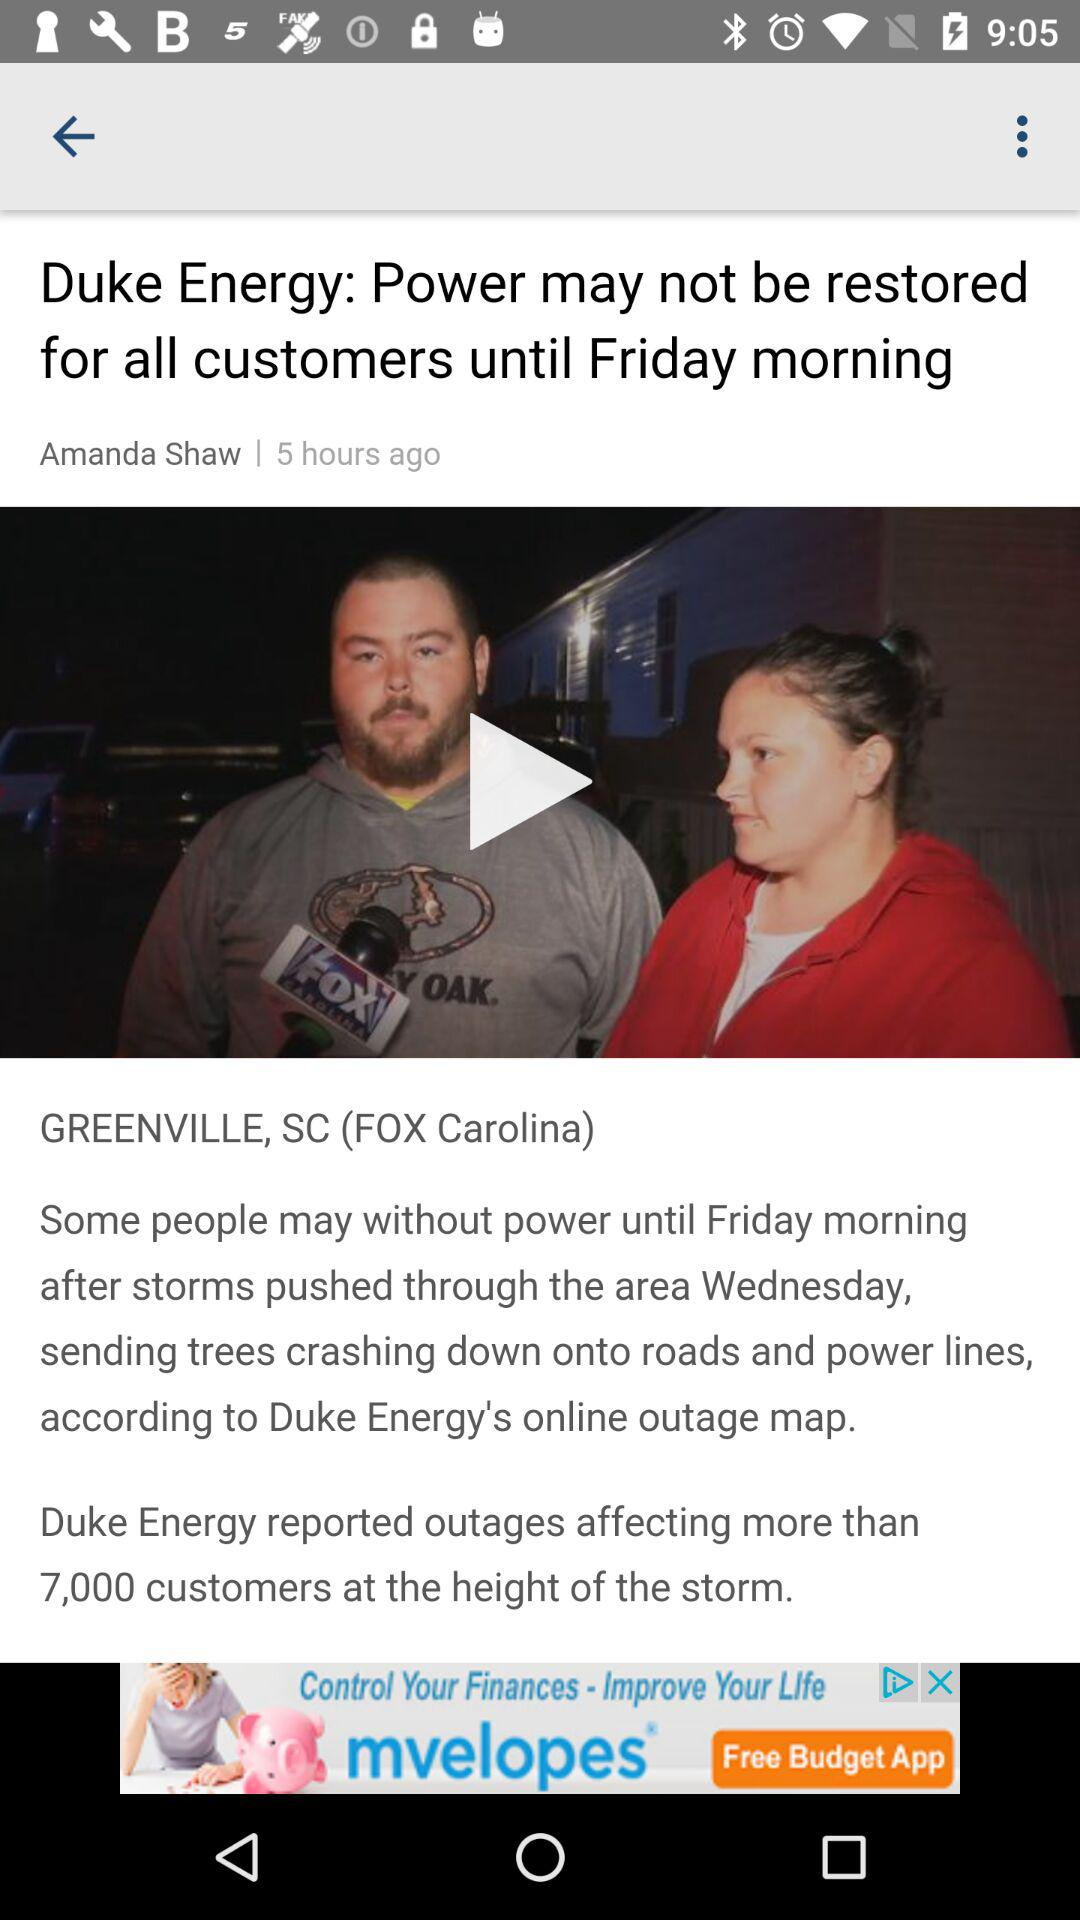How many hours ago was the article posted? The article was posted 5 hours ago. 